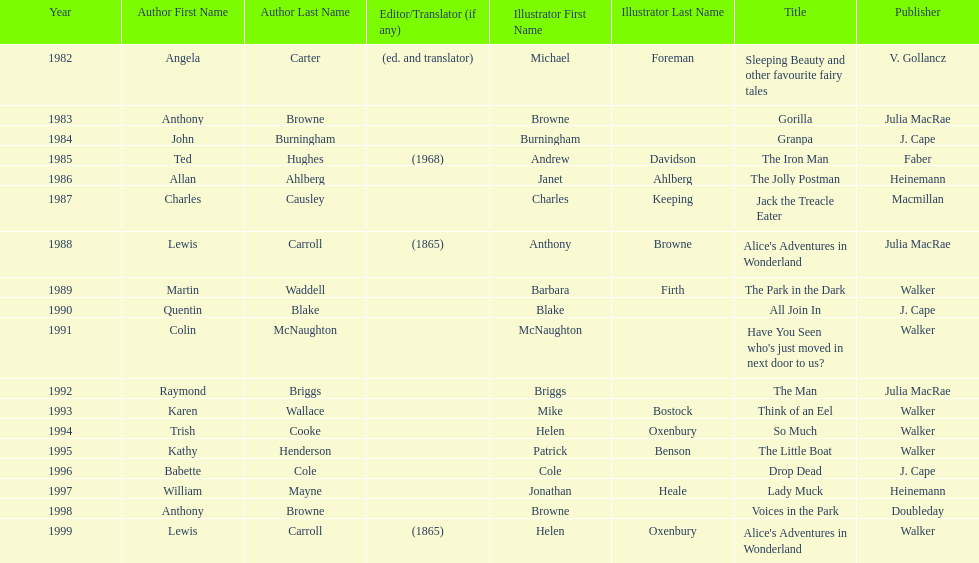How many times has anthony browne won an kurt maschler award for illustration? 3. 